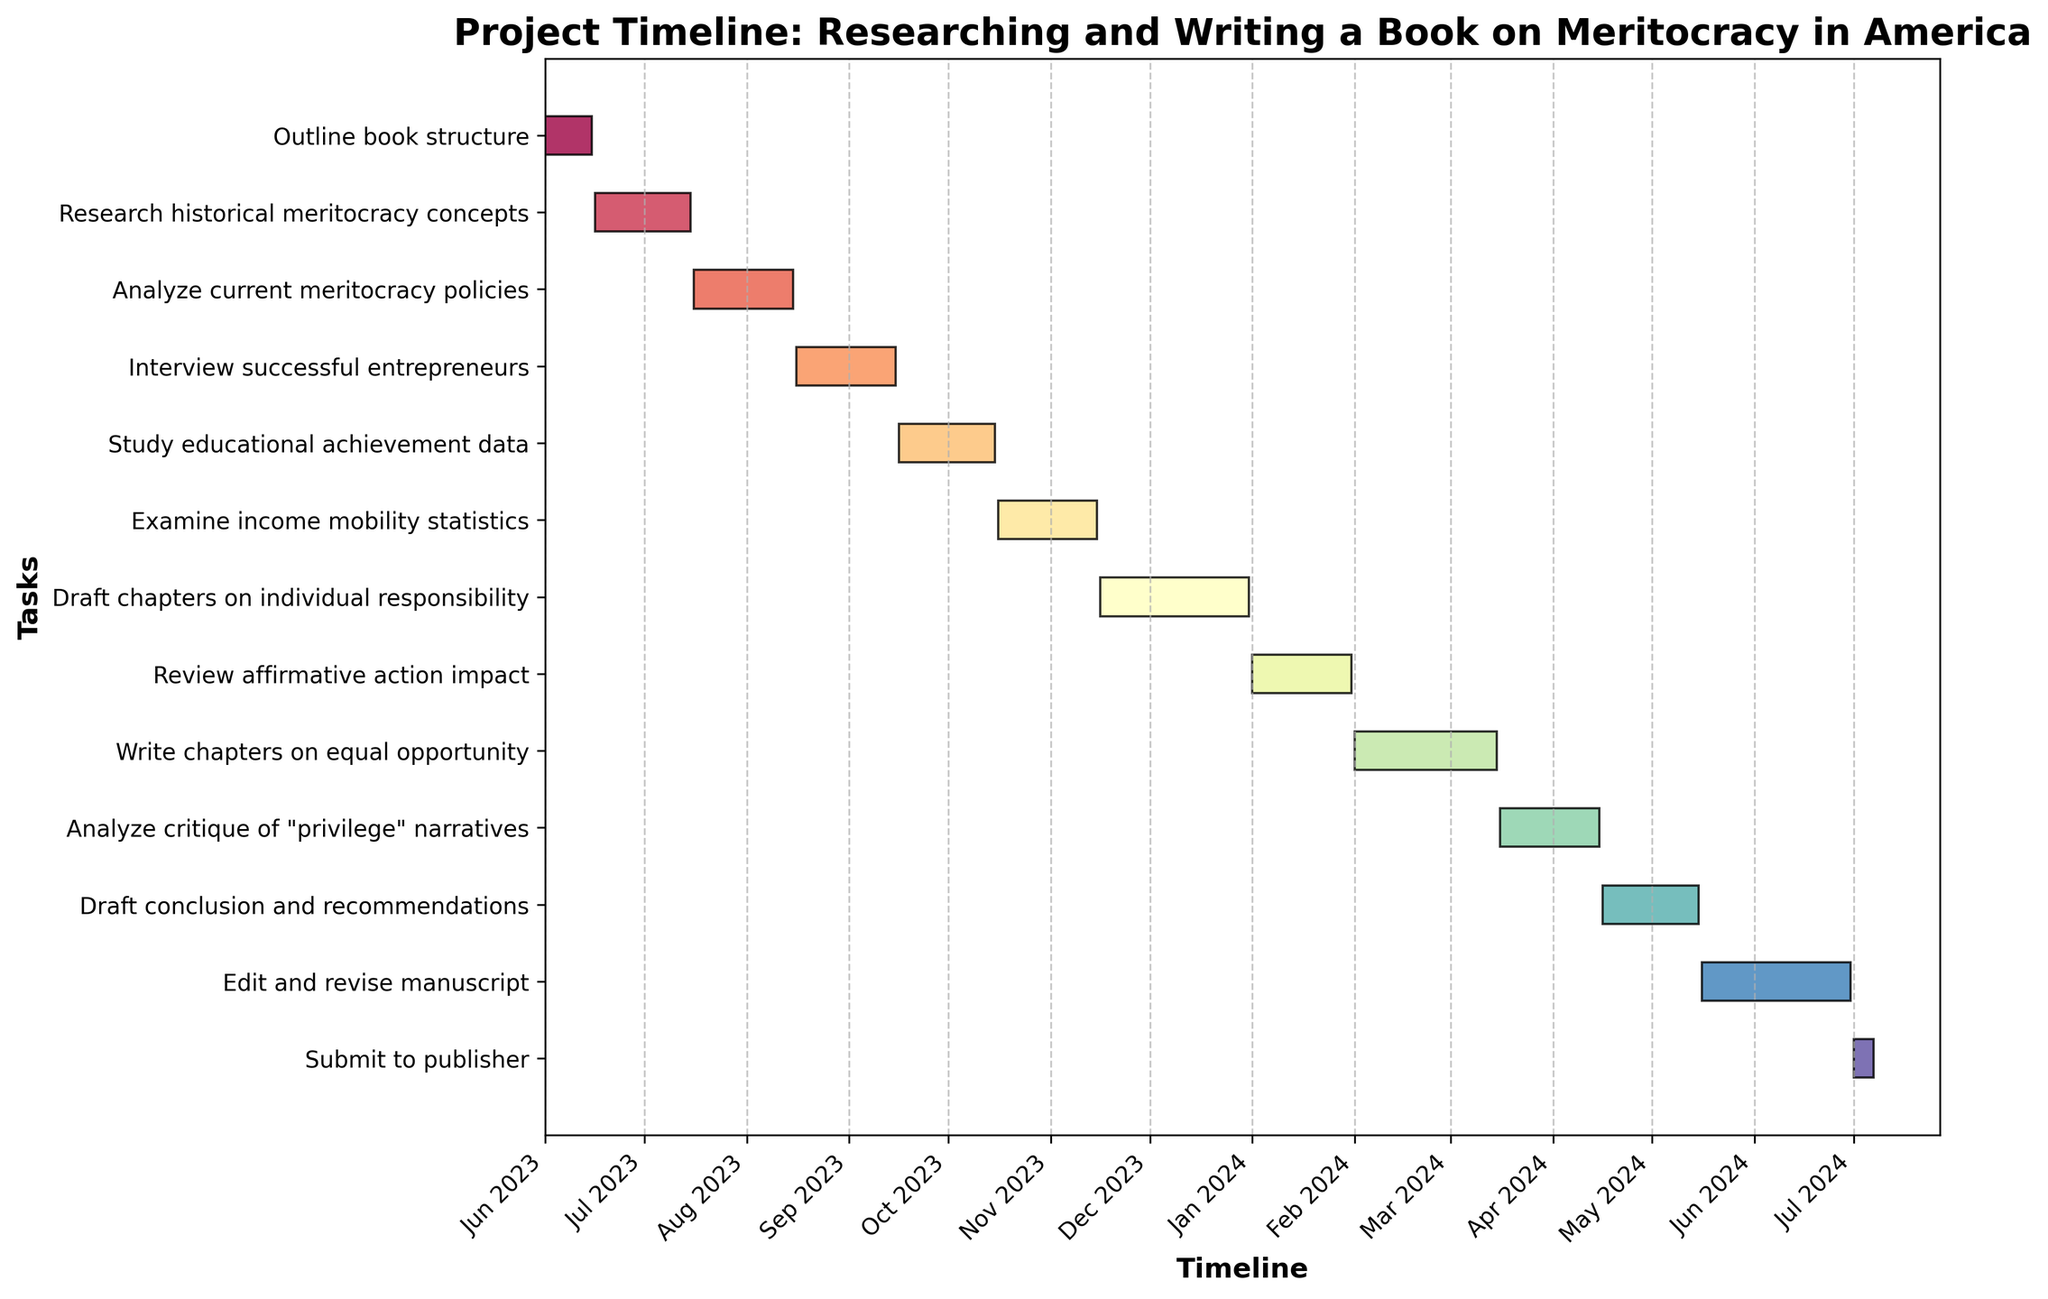What is the title of the Gantt chart? The title is located at the top of the chart in bold font. It describes the overall purpose of the chart.
Answer: Project Timeline: Researching and Writing a Book on Meritocracy in America How many tasks are included in the project? By counting the bars on the y-axis of the Gantt chart, one can determine the number of tasks.
Answer: 13 Which task has the longest duration? By comparing the lengths of the bars horizontally, one can identify the task that extends the furthest.
Answer: Draft chapters on individual responsibility What is the duration of the "Analyze current meritocracy policies" task? Each bar's length represents the duration. Observe the bar labeled "Analyze current meritocracy policies" to determine its length.
Answer: 31 days (July 16, 2023 - August 15, 2023) What are the start and end dates for "Study educational achievement data"? The start and end dates are marked at the beginning and end of each bar. For "Study educational achievement data," check its respective bar for dates.
Answer: September 16, 2023 - October 15, 2023 Which tasks are scheduled to be worked on in December 2023? Identify the bars that extend through December 2023 by examining their positions and durations.
Answer: Draft chapters on individual responsibility How many tasks extend across multiple months? Count the bars that span over at least two different month markers on the x-axis.
Answer: 10 Do any tasks overlap in their timelines? Give one example. Look for bars that occupy the same horizontal position (y-axis) during the same timeframe (x-axis).
Answer: Research historical meritocracy concepts and Analyze current meritocracy policies overlap in June 2023 Is there any task that will extend into the year 2024? Check for bars that extend past December 2023 into January 2024 or later.
Answer: Yes, Review affirmative action impact Which tasks are set to be completed in the first half of 2024? Focus on tasks with end dates between January 1, 2024, and June 30, 2024. List those found within this range.
Answer: Review affirmative action impact, Write chapters on equal opportunity, Analyze critique of "privilege" narratives, Draft conclusion and recommendations, Edit and revise manuscript 